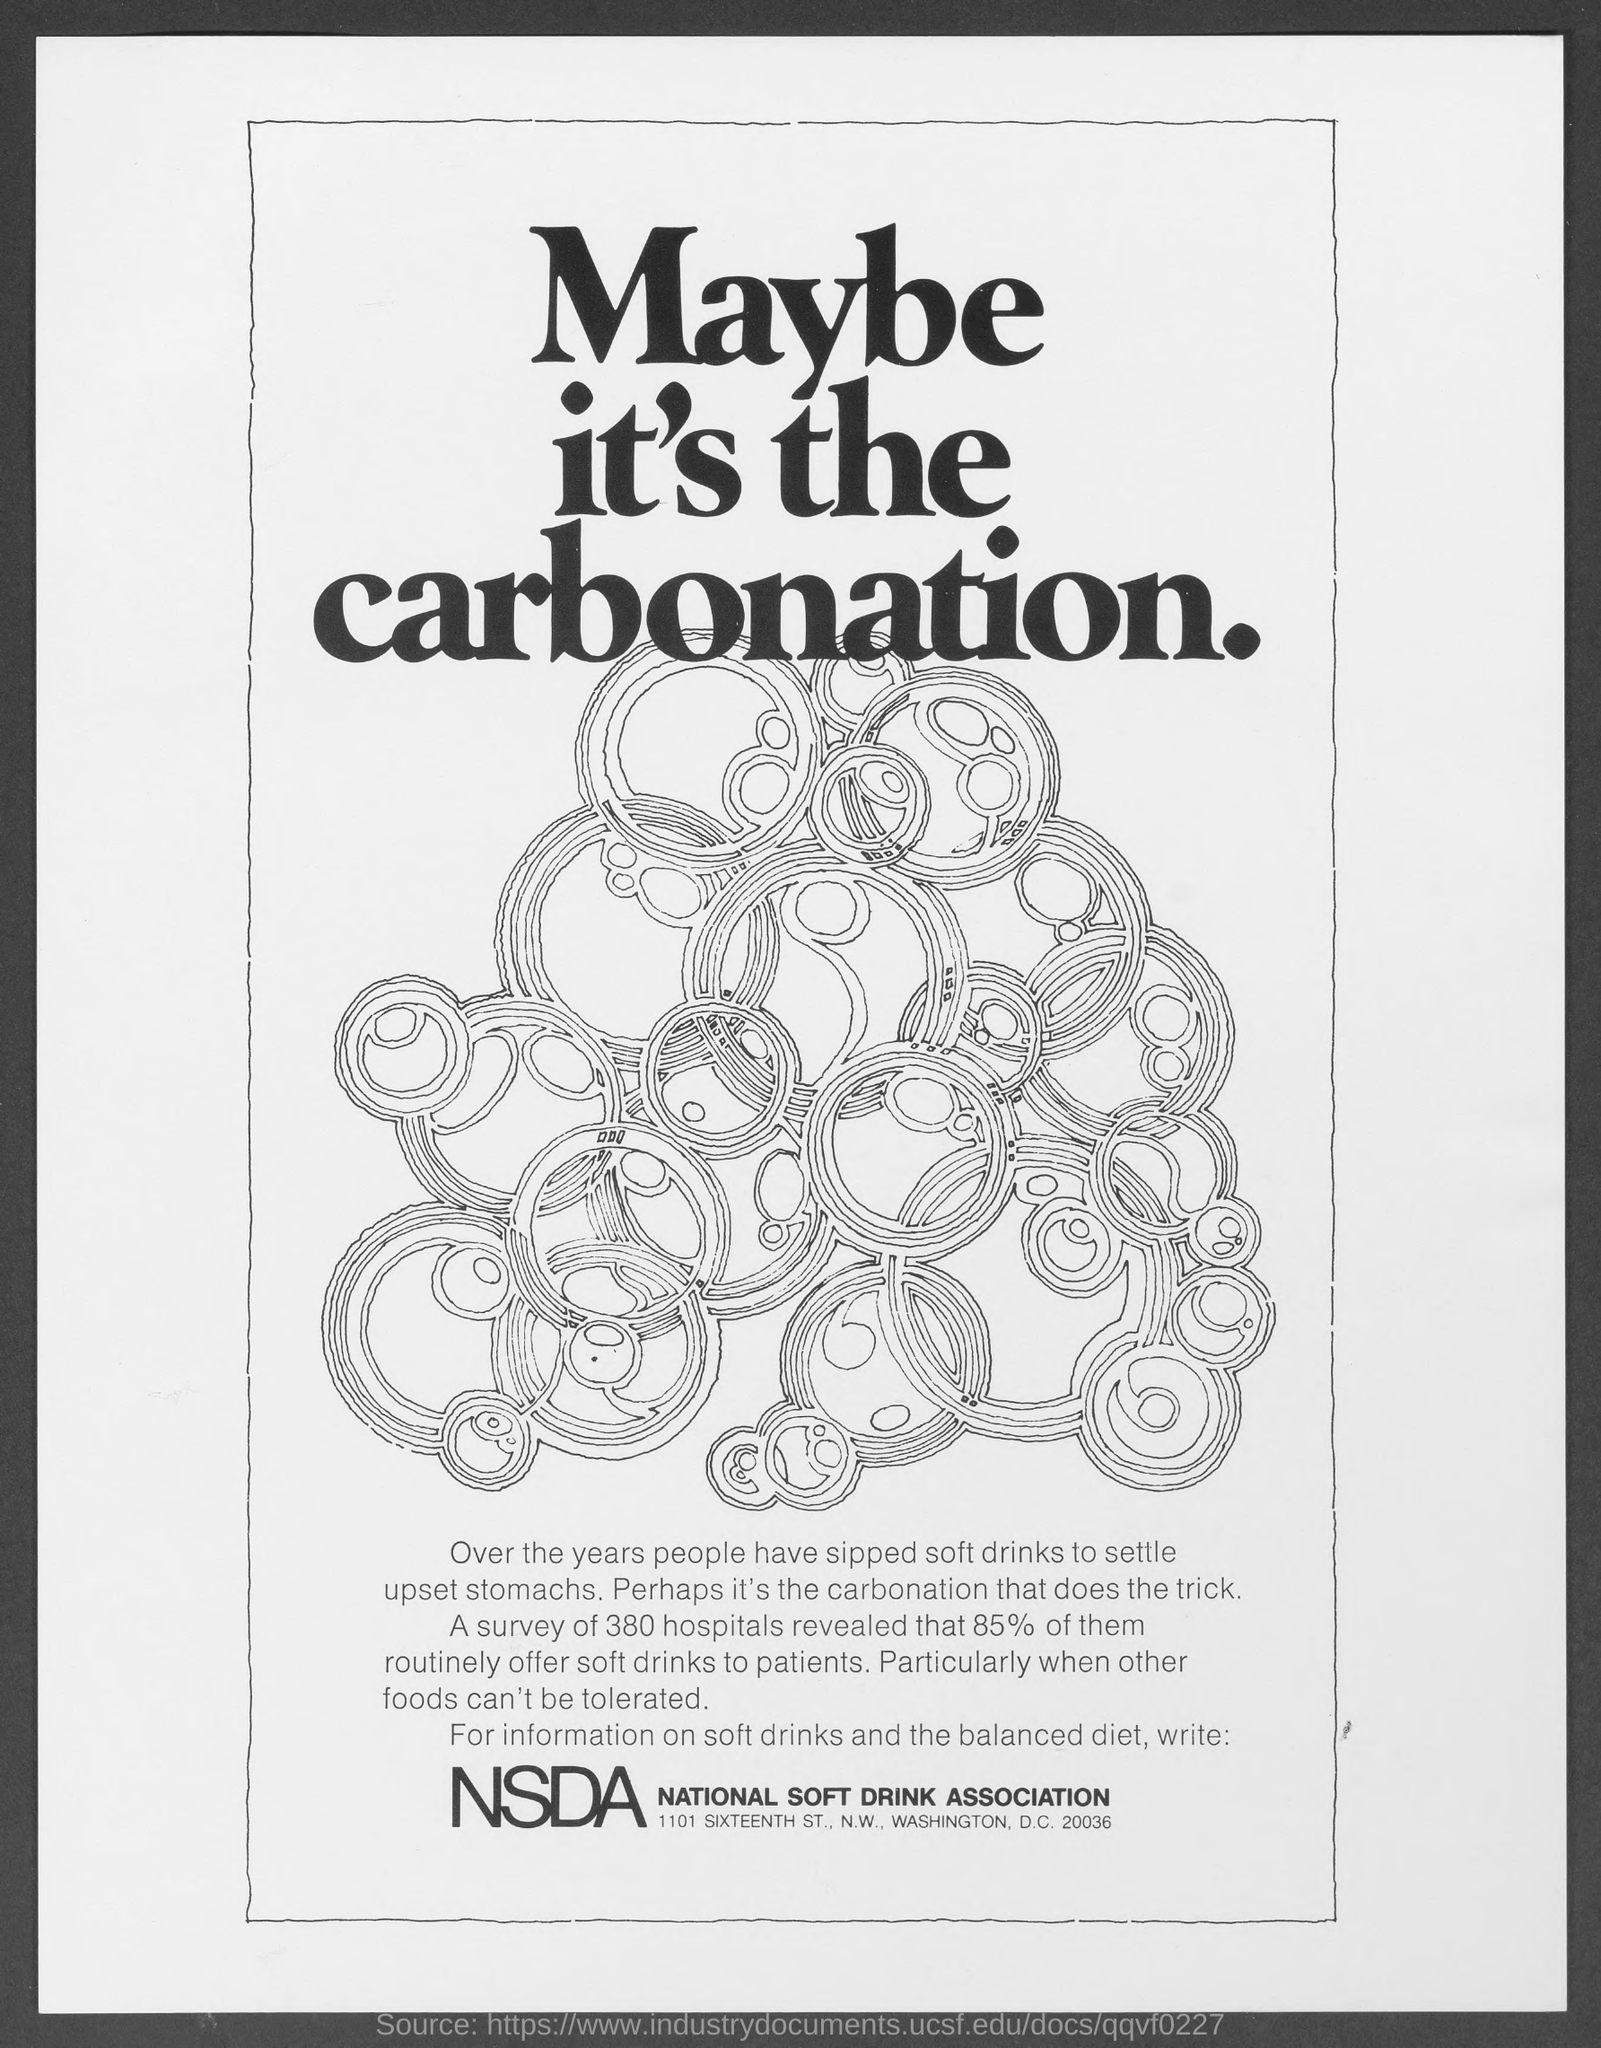Draw attention to some important aspects in this diagram. For years, people have turned to soft drinks to settle upset stomachs. A total of 380 hospitals were surveyed in this study. The survey revealed that out of the 350 hospitals surveyed, 85% of the hospitals routinely offer soft drinks to patients. 